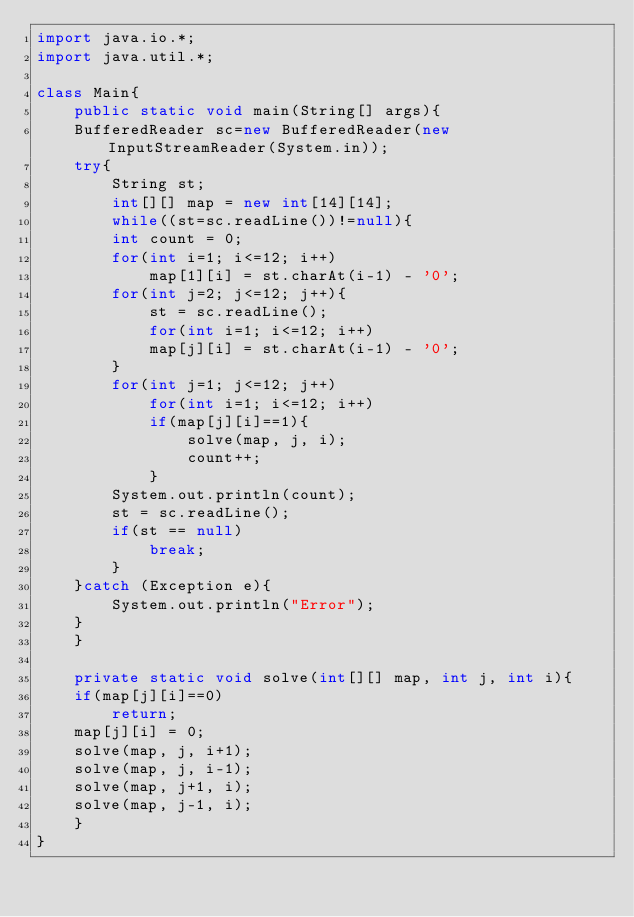Convert code to text. <code><loc_0><loc_0><loc_500><loc_500><_Java_>import java.io.*;
import java.util.*;

class Main{
    public static void main(String[] args){
	BufferedReader sc=new BufferedReader(new InputStreamReader(System.in));
	try{
	    String st;
	    int[][] map = new int[14][14];
	    while((st=sc.readLine())!=null){
		int count = 0;
		for(int i=1; i<=12; i++)
		    map[1][i] = st.charAt(i-1) - '0';
		for(int j=2; j<=12; j++){
		    st = sc.readLine();
		    for(int i=1; i<=12; i++)
			map[j][i] = st.charAt(i-1) - '0';
		}
		for(int j=1; j<=12; j++)
		    for(int i=1; i<=12; i++)
			if(map[j][i]==1){
			    solve(map, j, i);
			    count++;
			}
		System.out.println(count);
		st = sc.readLine();
		if(st == null)
		    break;
	    }
	}catch (Exception e){
	    System.out.println("Error");
	}
    }
    
    private static void solve(int[][] map, int j, int i){
	if(map[j][i]==0)
	    return;
	map[j][i] = 0;
	solve(map, j, i+1);
	solve(map, j, i-1);
	solve(map, j+1, i);
	solve(map, j-1, i);
    }
}</code> 